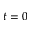<formula> <loc_0><loc_0><loc_500><loc_500>t = 0</formula> 